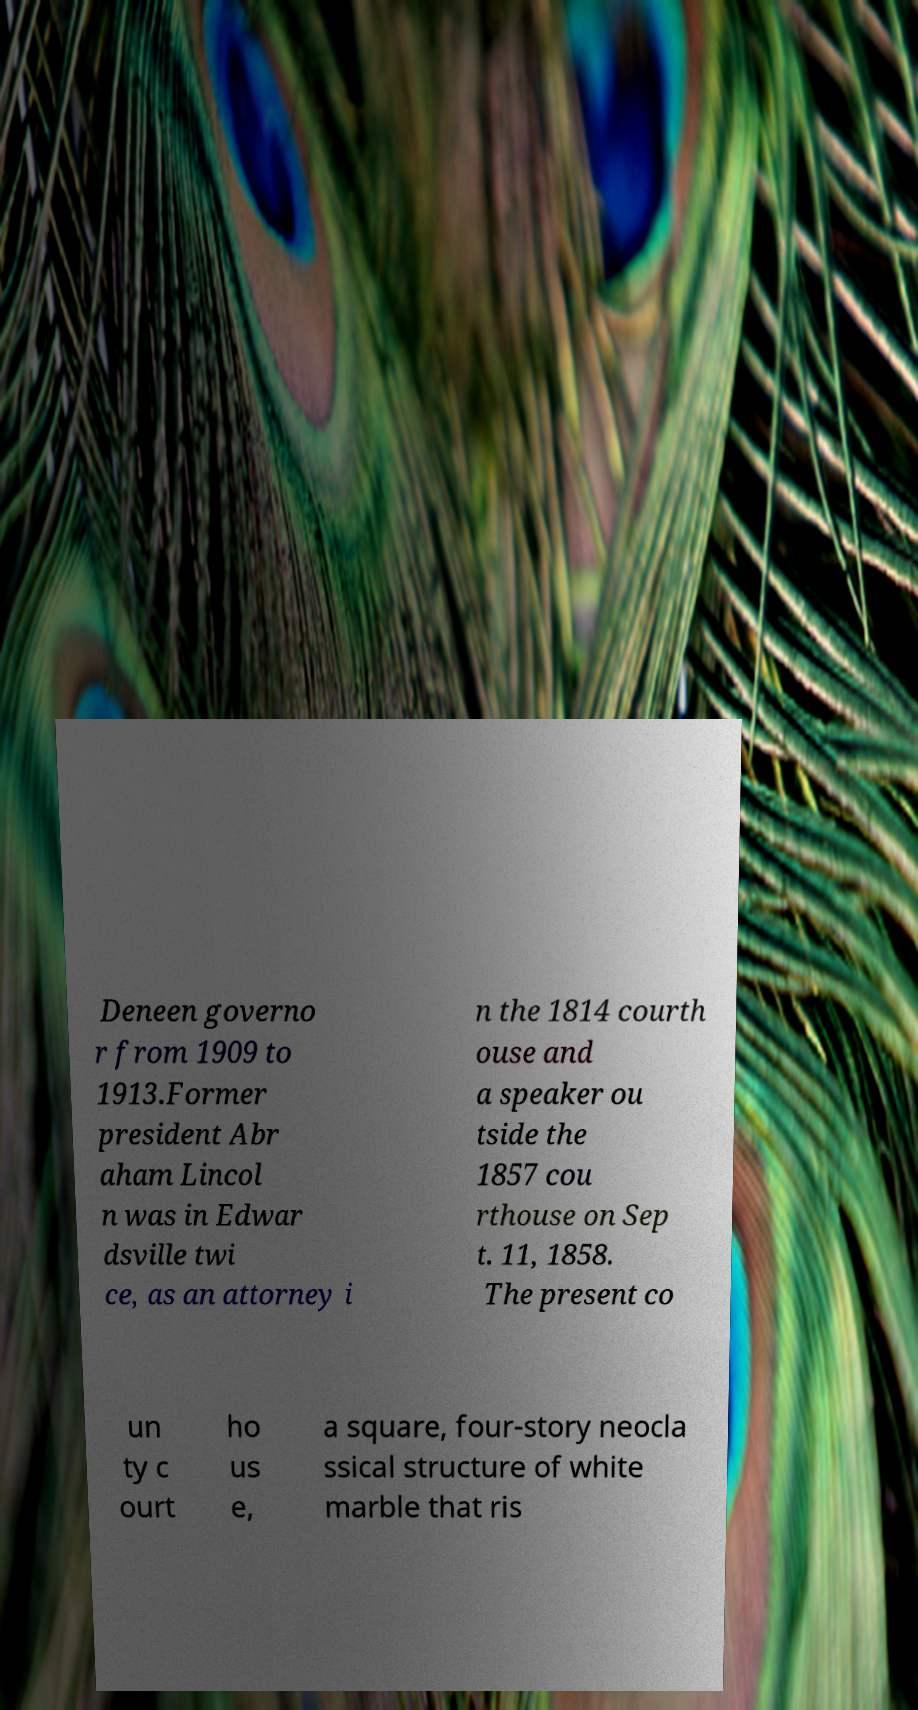What messages or text are displayed in this image? I need them in a readable, typed format. Deneen governo r from 1909 to 1913.Former president Abr aham Lincol n was in Edwar dsville twi ce, as an attorney i n the 1814 courth ouse and a speaker ou tside the 1857 cou rthouse on Sep t. 11, 1858. The present co un ty c ourt ho us e, a square, four-story neocla ssical structure of white marble that ris 